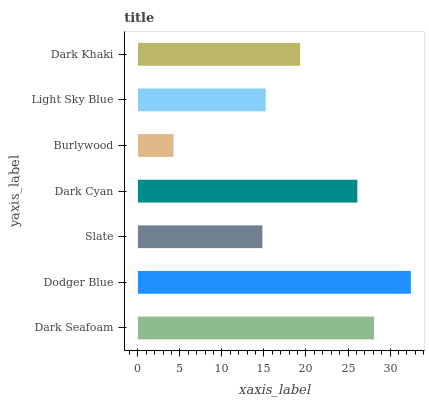Is Burlywood the minimum?
Answer yes or no. Yes. Is Dodger Blue the maximum?
Answer yes or no. Yes. Is Slate the minimum?
Answer yes or no. No. Is Slate the maximum?
Answer yes or no. No. Is Dodger Blue greater than Slate?
Answer yes or no. Yes. Is Slate less than Dodger Blue?
Answer yes or no. Yes. Is Slate greater than Dodger Blue?
Answer yes or no. No. Is Dodger Blue less than Slate?
Answer yes or no. No. Is Dark Khaki the high median?
Answer yes or no. Yes. Is Dark Khaki the low median?
Answer yes or no. Yes. Is Burlywood the high median?
Answer yes or no. No. Is Burlywood the low median?
Answer yes or no. No. 